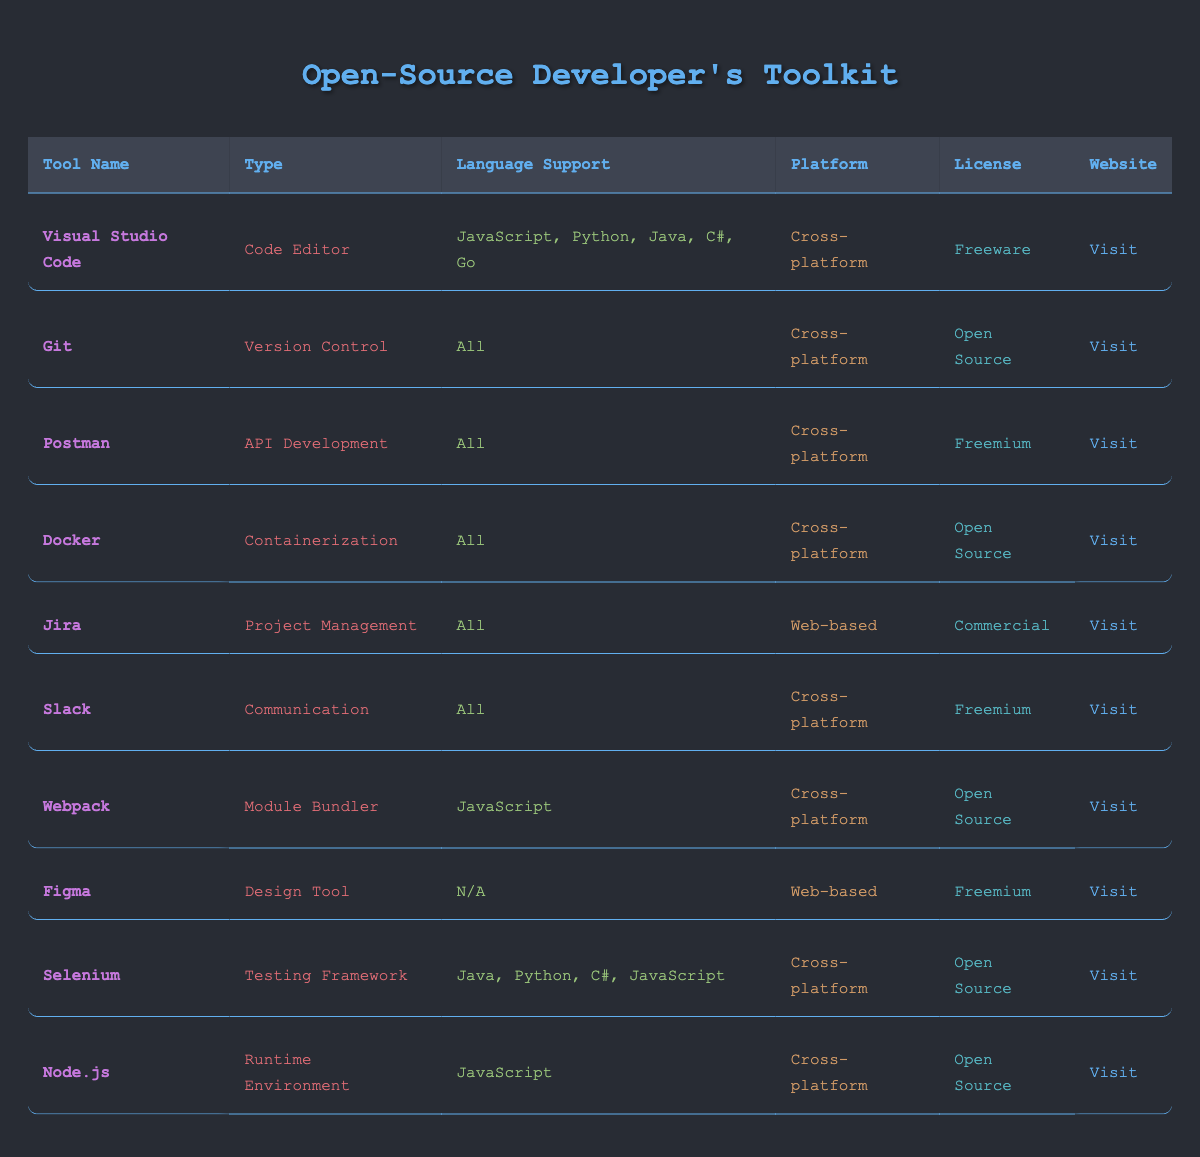What is the license type of Visual Studio Code? From the table, we can see a specific row dedicated to Visual Studio Code. Looking at the "License" column of that row, it states that Visual Studio Code is categorized as "Freeware."
Answer: Freeware Which tools are categorized as "Cross-platform"? By examining the "Platform" column in the table, we identify all rows that have "Cross-platform" listed. These tools include Visual Studio Code, Git, Postman, Docker, Slack, Webpack, Selenium, and Node.js.
Answer: Visual Studio Code, Git, Postman, Docker, Slack, Webpack, Selenium, Node.js How many tools support the Java programming language? We go through the "Language Support" column and identify which tools include "Java" in their supported languages. The tools with Java support are Selenium and Visual Studio Code. We count these to get the total number, which is 2.
Answer: 2 Is there any tool in the inventory that is categorized as a "Testing Framework"? We look down the "Type" column for the term "Testing Framework." There is a tool, Selenium, which falls under this category. Therefore, the answer is affirmatively "Yes."
Answer: Yes Which tool offers a freemium license that is also cross-platform? We scan both the "License" and "Platform" columns to find tools that have "Freemium" as their license type and "Cross-platform" as their platform. The only tool that meets both criteria is Slack.
Answer: Slack List the tools that support JavaScript. By scanning the "Language Support" column, we find that the tools supporting JavaScript are Visual Studio Code, Webpack, Selenium, and Node.js. Thus, these are the tools that can be listed.
Answer: Visual Studio Code, Webpack, Selenium, Node.js What is the website link for Jira? The table includes a direct link under the "Website" column for each tool. For Jira, it is provided as "https://www.atlassian.com/software/jira".
Answer: https://www.atlassian.com/software/jira How many tools are categorized as "Commercial" based on the license? We refer to the "License" column to find tools that are marked as "Commercial." Only one tool, Jira, has this license type. Thus, we conclude with the total as 1.
Answer: 1 Are there any tools that serve the purpose of API development? Checking the "Type" column, we find that only one tool, Postman, is categorized under API Development. Therefore, the answer is affirmatively "Yes."
Answer: Yes 